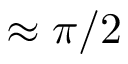Convert formula to latex. <formula><loc_0><loc_0><loc_500><loc_500>\approx \pi / 2</formula> 